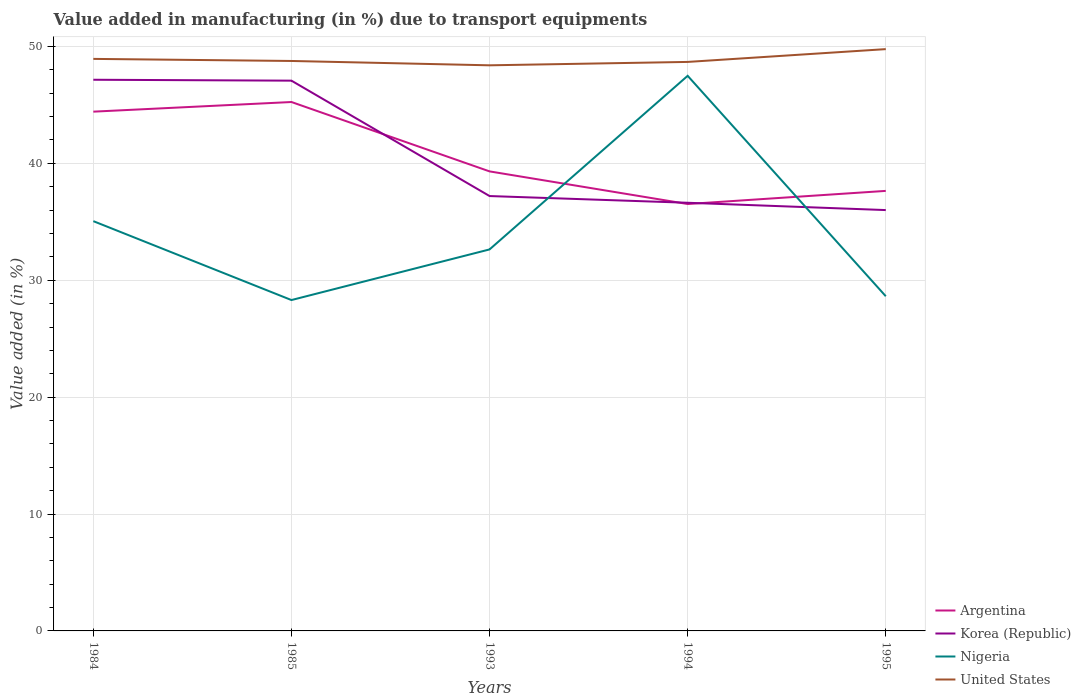How many different coloured lines are there?
Keep it short and to the point. 4. Does the line corresponding to United States intersect with the line corresponding to Nigeria?
Ensure brevity in your answer.  No. Across all years, what is the maximum percentage of value added in manufacturing due to transport equipments in Nigeria?
Your response must be concise. 28.31. In which year was the percentage of value added in manufacturing due to transport equipments in United States maximum?
Provide a succinct answer. 1993. What is the total percentage of value added in manufacturing due to transport equipments in United States in the graph?
Give a very brief answer. 0.55. What is the difference between the highest and the second highest percentage of value added in manufacturing due to transport equipments in Nigeria?
Offer a very short reply. 19.18. How many years are there in the graph?
Provide a succinct answer. 5. What is the difference between two consecutive major ticks on the Y-axis?
Provide a short and direct response. 10. Are the values on the major ticks of Y-axis written in scientific E-notation?
Your answer should be very brief. No. Does the graph contain grids?
Make the answer very short. Yes. What is the title of the graph?
Give a very brief answer. Value added in manufacturing (in %) due to transport equipments. Does "Namibia" appear as one of the legend labels in the graph?
Offer a terse response. No. What is the label or title of the X-axis?
Provide a succinct answer. Years. What is the label or title of the Y-axis?
Your answer should be very brief. Value added (in %). What is the Value added (in %) in Argentina in 1984?
Provide a short and direct response. 44.42. What is the Value added (in %) of Korea (Republic) in 1984?
Give a very brief answer. 47.15. What is the Value added (in %) of Nigeria in 1984?
Ensure brevity in your answer.  35.06. What is the Value added (in %) of United States in 1984?
Offer a very short reply. 48.94. What is the Value added (in %) in Argentina in 1985?
Your answer should be compact. 45.25. What is the Value added (in %) of Korea (Republic) in 1985?
Provide a short and direct response. 47.08. What is the Value added (in %) of Nigeria in 1985?
Offer a terse response. 28.31. What is the Value added (in %) of United States in 1985?
Offer a terse response. 48.76. What is the Value added (in %) of Argentina in 1993?
Give a very brief answer. 39.31. What is the Value added (in %) in Korea (Republic) in 1993?
Provide a succinct answer. 37.21. What is the Value added (in %) of Nigeria in 1993?
Your response must be concise. 32.64. What is the Value added (in %) in United States in 1993?
Provide a short and direct response. 48.39. What is the Value added (in %) in Argentina in 1994?
Provide a succinct answer. 36.52. What is the Value added (in %) in Korea (Republic) in 1994?
Give a very brief answer. 36.63. What is the Value added (in %) in Nigeria in 1994?
Your response must be concise. 47.49. What is the Value added (in %) of United States in 1994?
Your answer should be very brief. 48.68. What is the Value added (in %) in Argentina in 1995?
Give a very brief answer. 37.65. What is the Value added (in %) of Korea (Republic) in 1995?
Provide a short and direct response. 36. What is the Value added (in %) of Nigeria in 1995?
Your answer should be compact. 28.63. What is the Value added (in %) of United States in 1995?
Make the answer very short. 49.77. Across all years, what is the maximum Value added (in %) of Argentina?
Provide a succinct answer. 45.25. Across all years, what is the maximum Value added (in %) of Korea (Republic)?
Give a very brief answer. 47.15. Across all years, what is the maximum Value added (in %) in Nigeria?
Offer a very short reply. 47.49. Across all years, what is the maximum Value added (in %) of United States?
Provide a succinct answer. 49.77. Across all years, what is the minimum Value added (in %) in Argentina?
Offer a terse response. 36.52. Across all years, what is the minimum Value added (in %) of Korea (Republic)?
Your answer should be very brief. 36. Across all years, what is the minimum Value added (in %) of Nigeria?
Your response must be concise. 28.31. Across all years, what is the minimum Value added (in %) in United States?
Offer a terse response. 48.39. What is the total Value added (in %) in Argentina in the graph?
Your answer should be compact. 203.16. What is the total Value added (in %) of Korea (Republic) in the graph?
Your response must be concise. 204.07. What is the total Value added (in %) in Nigeria in the graph?
Ensure brevity in your answer.  172.13. What is the total Value added (in %) of United States in the graph?
Give a very brief answer. 244.54. What is the difference between the Value added (in %) of Argentina in 1984 and that in 1985?
Provide a short and direct response. -0.83. What is the difference between the Value added (in %) of Korea (Republic) in 1984 and that in 1985?
Offer a very short reply. 0.08. What is the difference between the Value added (in %) in Nigeria in 1984 and that in 1985?
Offer a very short reply. 6.75. What is the difference between the Value added (in %) in United States in 1984 and that in 1985?
Offer a very short reply. 0.18. What is the difference between the Value added (in %) of Argentina in 1984 and that in 1993?
Your answer should be compact. 5.11. What is the difference between the Value added (in %) of Korea (Republic) in 1984 and that in 1993?
Provide a succinct answer. 9.95. What is the difference between the Value added (in %) of Nigeria in 1984 and that in 1993?
Give a very brief answer. 2.42. What is the difference between the Value added (in %) of United States in 1984 and that in 1993?
Give a very brief answer. 0.55. What is the difference between the Value added (in %) in Argentina in 1984 and that in 1994?
Offer a very short reply. 7.9. What is the difference between the Value added (in %) of Korea (Republic) in 1984 and that in 1994?
Ensure brevity in your answer.  10.52. What is the difference between the Value added (in %) in Nigeria in 1984 and that in 1994?
Make the answer very short. -12.43. What is the difference between the Value added (in %) of United States in 1984 and that in 1994?
Provide a succinct answer. 0.26. What is the difference between the Value added (in %) in Argentina in 1984 and that in 1995?
Your response must be concise. 6.78. What is the difference between the Value added (in %) in Korea (Republic) in 1984 and that in 1995?
Offer a very short reply. 11.15. What is the difference between the Value added (in %) in Nigeria in 1984 and that in 1995?
Offer a terse response. 6.42. What is the difference between the Value added (in %) in United States in 1984 and that in 1995?
Ensure brevity in your answer.  -0.84. What is the difference between the Value added (in %) of Argentina in 1985 and that in 1993?
Make the answer very short. 5.94. What is the difference between the Value added (in %) of Korea (Republic) in 1985 and that in 1993?
Offer a terse response. 9.87. What is the difference between the Value added (in %) in Nigeria in 1985 and that in 1993?
Make the answer very short. -4.33. What is the difference between the Value added (in %) in United States in 1985 and that in 1993?
Your answer should be compact. 0.37. What is the difference between the Value added (in %) of Argentina in 1985 and that in 1994?
Offer a very short reply. 8.73. What is the difference between the Value added (in %) in Korea (Republic) in 1985 and that in 1994?
Keep it short and to the point. 10.45. What is the difference between the Value added (in %) of Nigeria in 1985 and that in 1994?
Make the answer very short. -19.18. What is the difference between the Value added (in %) of United States in 1985 and that in 1994?
Offer a very short reply. 0.08. What is the difference between the Value added (in %) in Argentina in 1985 and that in 1995?
Your response must be concise. 7.6. What is the difference between the Value added (in %) of Korea (Republic) in 1985 and that in 1995?
Your answer should be compact. 11.07. What is the difference between the Value added (in %) of Nigeria in 1985 and that in 1995?
Your answer should be compact. -0.33. What is the difference between the Value added (in %) in United States in 1985 and that in 1995?
Make the answer very short. -1.01. What is the difference between the Value added (in %) of Argentina in 1993 and that in 1994?
Your response must be concise. 2.79. What is the difference between the Value added (in %) in Korea (Republic) in 1993 and that in 1994?
Your answer should be very brief. 0.57. What is the difference between the Value added (in %) of Nigeria in 1993 and that in 1994?
Provide a short and direct response. -14.85. What is the difference between the Value added (in %) of United States in 1993 and that in 1994?
Make the answer very short. -0.29. What is the difference between the Value added (in %) of Argentina in 1993 and that in 1995?
Your answer should be very brief. 1.67. What is the difference between the Value added (in %) of Korea (Republic) in 1993 and that in 1995?
Ensure brevity in your answer.  1.2. What is the difference between the Value added (in %) in Nigeria in 1993 and that in 1995?
Keep it short and to the point. 4.01. What is the difference between the Value added (in %) in United States in 1993 and that in 1995?
Your answer should be very brief. -1.39. What is the difference between the Value added (in %) in Argentina in 1994 and that in 1995?
Your response must be concise. -1.12. What is the difference between the Value added (in %) of Korea (Republic) in 1994 and that in 1995?
Offer a terse response. 0.63. What is the difference between the Value added (in %) in Nigeria in 1994 and that in 1995?
Give a very brief answer. 18.86. What is the difference between the Value added (in %) of United States in 1994 and that in 1995?
Your answer should be very brief. -1.1. What is the difference between the Value added (in %) of Argentina in 1984 and the Value added (in %) of Korea (Republic) in 1985?
Your answer should be very brief. -2.65. What is the difference between the Value added (in %) in Argentina in 1984 and the Value added (in %) in Nigeria in 1985?
Make the answer very short. 16.12. What is the difference between the Value added (in %) in Argentina in 1984 and the Value added (in %) in United States in 1985?
Your answer should be very brief. -4.34. What is the difference between the Value added (in %) of Korea (Republic) in 1984 and the Value added (in %) of Nigeria in 1985?
Provide a short and direct response. 18.85. What is the difference between the Value added (in %) in Korea (Republic) in 1984 and the Value added (in %) in United States in 1985?
Make the answer very short. -1.61. What is the difference between the Value added (in %) of Nigeria in 1984 and the Value added (in %) of United States in 1985?
Ensure brevity in your answer.  -13.7. What is the difference between the Value added (in %) of Argentina in 1984 and the Value added (in %) of Korea (Republic) in 1993?
Give a very brief answer. 7.22. What is the difference between the Value added (in %) in Argentina in 1984 and the Value added (in %) in Nigeria in 1993?
Provide a succinct answer. 11.79. What is the difference between the Value added (in %) of Argentina in 1984 and the Value added (in %) of United States in 1993?
Your answer should be very brief. -3.97. What is the difference between the Value added (in %) in Korea (Republic) in 1984 and the Value added (in %) in Nigeria in 1993?
Offer a terse response. 14.52. What is the difference between the Value added (in %) of Korea (Republic) in 1984 and the Value added (in %) of United States in 1993?
Provide a succinct answer. -1.24. What is the difference between the Value added (in %) in Nigeria in 1984 and the Value added (in %) in United States in 1993?
Your answer should be compact. -13.33. What is the difference between the Value added (in %) in Argentina in 1984 and the Value added (in %) in Korea (Republic) in 1994?
Offer a very short reply. 7.79. What is the difference between the Value added (in %) in Argentina in 1984 and the Value added (in %) in Nigeria in 1994?
Your response must be concise. -3.07. What is the difference between the Value added (in %) in Argentina in 1984 and the Value added (in %) in United States in 1994?
Keep it short and to the point. -4.25. What is the difference between the Value added (in %) of Korea (Republic) in 1984 and the Value added (in %) of Nigeria in 1994?
Provide a short and direct response. -0.34. What is the difference between the Value added (in %) of Korea (Republic) in 1984 and the Value added (in %) of United States in 1994?
Provide a short and direct response. -1.53. What is the difference between the Value added (in %) of Nigeria in 1984 and the Value added (in %) of United States in 1994?
Give a very brief answer. -13.62. What is the difference between the Value added (in %) of Argentina in 1984 and the Value added (in %) of Korea (Republic) in 1995?
Provide a short and direct response. 8.42. What is the difference between the Value added (in %) of Argentina in 1984 and the Value added (in %) of Nigeria in 1995?
Offer a terse response. 15.79. What is the difference between the Value added (in %) in Argentina in 1984 and the Value added (in %) in United States in 1995?
Offer a terse response. -5.35. What is the difference between the Value added (in %) in Korea (Republic) in 1984 and the Value added (in %) in Nigeria in 1995?
Provide a short and direct response. 18.52. What is the difference between the Value added (in %) of Korea (Republic) in 1984 and the Value added (in %) of United States in 1995?
Offer a very short reply. -2.62. What is the difference between the Value added (in %) in Nigeria in 1984 and the Value added (in %) in United States in 1995?
Your response must be concise. -14.72. What is the difference between the Value added (in %) in Argentina in 1985 and the Value added (in %) in Korea (Republic) in 1993?
Ensure brevity in your answer.  8.04. What is the difference between the Value added (in %) of Argentina in 1985 and the Value added (in %) of Nigeria in 1993?
Your response must be concise. 12.61. What is the difference between the Value added (in %) in Argentina in 1985 and the Value added (in %) in United States in 1993?
Your answer should be very brief. -3.14. What is the difference between the Value added (in %) in Korea (Republic) in 1985 and the Value added (in %) in Nigeria in 1993?
Give a very brief answer. 14.44. What is the difference between the Value added (in %) in Korea (Republic) in 1985 and the Value added (in %) in United States in 1993?
Your answer should be compact. -1.31. What is the difference between the Value added (in %) of Nigeria in 1985 and the Value added (in %) of United States in 1993?
Provide a succinct answer. -20.08. What is the difference between the Value added (in %) in Argentina in 1985 and the Value added (in %) in Korea (Republic) in 1994?
Make the answer very short. 8.62. What is the difference between the Value added (in %) of Argentina in 1985 and the Value added (in %) of Nigeria in 1994?
Your answer should be very brief. -2.24. What is the difference between the Value added (in %) in Argentina in 1985 and the Value added (in %) in United States in 1994?
Offer a terse response. -3.43. What is the difference between the Value added (in %) in Korea (Republic) in 1985 and the Value added (in %) in Nigeria in 1994?
Offer a very short reply. -0.41. What is the difference between the Value added (in %) in Korea (Republic) in 1985 and the Value added (in %) in United States in 1994?
Make the answer very short. -1.6. What is the difference between the Value added (in %) of Nigeria in 1985 and the Value added (in %) of United States in 1994?
Offer a very short reply. -20.37. What is the difference between the Value added (in %) of Argentina in 1985 and the Value added (in %) of Korea (Republic) in 1995?
Offer a very short reply. 9.25. What is the difference between the Value added (in %) in Argentina in 1985 and the Value added (in %) in Nigeria in 1995?
Provide a short and direct response. 16.62. What is the difference between the Value added (in %) in Argentina in 1985 and the Value added (in %) in United States in 1995?
Give a very brief answer. -4.52. What is the difference between the Value added (in %) in Korea (Republic) in 1985 and the Value added (in %) in Nigeria in 1995?
Provide a succinct answer. 18.44. What is the difference between the Value added (in %) in Korea (Republic) in 1985 and the Value added (in %) in United States in 1995?
Give a very brief answer. -2.7. What is the difference between the Value added (in %) of Nigeria in 1985 and the Value added (in %) of United States in 1995?
Offer a terse response. -21.47. What is the difference between the Value added (in %) of Argentina in 1993 and the Value added (in %) of Korea (Republic) in 1994?
Your response must be concise. 2.68. What is the difference between the Value added (in %) in Argentina in 1993 and the Value added (in %) in Nigeria in 1994?
Give a very brief answer. -8.18. What is the difference between the Value added (in %) of Argentina in 1993 and the Value added (in %) of United States in 1994?
Your answer should be compact. -9.37. What is the difference between the Value added (in %) of Korea (Republic) in 1993 and the Value added (in %) of Nigeria in 1994?
Give a very brief answer. -10.29. What is the difference between the Value added (in %) of Korea (Republic) in 1993 and the Value added (in %) of United States in 1994?
Your response must be concise. -11.47. What is the difference between the Value added (in %) in Nigeria in 1993 and the Value added (in %) in United States in 1994?
Make the answer very short. -16.04. What is the difference between the Value added (in %) in Argentina in 1993 and the Value added (in %) in Korea (Republic) in 1995?
Offer a very short reply. 3.31. What is the difference between the Value added (in %) in Argentina in 1993 and the Value added (in %) in Nigeria in 1995?
Offer a terse response. 10.68. What is the difference between the Value added (in %) of Argentina in 1993 and the Value added (in %) of United States in 1995?
Your answer should be compact. -10.46. What is the difference between the Value added (in %) of Korea (Republic) in 1993 and the Value added (in %) of Nigeria in 1995?
Make the answer very short. 8.57. What is the difference between the Value added (in %) in Korea (Republic) in 1993 and the Value added (in %) in United States in 1995?
Your response must be concise. -12.57. What is the difference between the Value added (in %) of Nigeria in 1993 and the Value added (in %) of United States in 1995?
Keep it short and to the point. -17.14. What is the difference between the Value added (in %) of Argentina in 1994 and the Value added (in %) of Korea (Republic) in 1995?
Your response must be concise. 0.52. What is the difference between the Value added (in %) in Argentina in 1994 and the Value added (in %) in Nigeria in 1995?
Your answer should be very brief. 7.89. What is the difference between the Value added (in %) of Argentina in 1994 and the Value added (in %) of United States in 1995?
Give a very brief answer. -13.25. What is the difference between the Value added (in %) of Korea (Republic) in 1994 and the Value added (in %) of Nigeria in 1995?
Give a very brief answer. 8. What is the difference between the Value added (in %) in Korea (Republic) in 1994 and the Value added (in %) in United States in 1995?
Offer a very short reply. -13.14. What is the difference between the Value added (in %) in Nigeria in 1994 and the Value added (in %) in United States in 1995?
Your answer should be compact. -2.28. What is the average Value added (in %) in Argentina per year?
Your response must be concise. 40.63. What is the average Value added (in %) of Korea (Republic) per year?
Offer a very short reply. 40.81. What is the average Value added (in %) of Nigeria per year?
Your answer should be compact. 34.43. What is the average Value added (in %) in United States per year?
Your answer should be very brief. 48.91. In the year 1984, what is the difference between the Value added (in %) in Argentina and Value added (in %) in Korea (Republic)?
Ensure brevity in your answer.  -2.73. In the year 1984, what is the difference between the Value added (in %) in Argentina and Value added (in %) in Nigeria?
Your answer should be very brief. 9.37. In the year 1984, what is the difference between the Value added (in %) in Argentina and Value added (in %) in United States?
Provide a succinct answer. -4.51. In the year 1984, what is the difference between the Value added (in %) in Korea (Republic) and Value added (in %) in Nigeria?
Provide a succinct answer. 12.1. In the year 1984, what is the difference between the Value added (in %) of Korea (Republic) and Value added (in %) of United States?
Offer a terse response. -1.78. In the year 1984, what is the difference between the Value added (in %) in Nigeria and Value added (in %) in United States?
Your answer should be compact. -13.88. In the year 1985, what is the difference between the Value added (in %) in Argentina and Value added (in %) in Korea (Republic)?
Provide a succinct answer. -1.83. In the year 1985, what is the difference between the Value added (in %) of Argentina and Value added (in %) of Nigeria?
Your answer should be very brief. 16.94. In the year 1985, what is the difference between the Value added (in %) in Argentina and Value added (in %) in United States?
Provide a short and direct response. -3.51. In the year 1985, what is the difference between the Value added (in %) of Korea (Republic) and Value added (in %) of Nigeria?
Your response must be concise. 18.77. In the year 1985, what is the difference between the Value added (in %) of Korea (Republic) and Value added (in %) of United States?
Offer a very short reply. -1.68. In the year 1985, what is the difference between the Value added (in %) in Nigeria and Value added (in %) in United States?
Offer a terse response. -20.45. In the year 1993, what is the difference between the Value added (in %) of Argentina and Value added (in %) of Korea (Republic)?
Give a very brief answer. 2.11. In the year 1993, what is the difference between the Value added (in %) in Argentina and Value added (in %) in Nigeria?
Your response must be concise. 6.68. In the year 1993, what is the difference between the Value added (in %) of Argentina and Value added (in %) of United States?
Your answer should be very brief. -9.08. In the year 1993, what is the difference between the Value added (in %) of Korea (Republic) and Value added (in %) of Nigeria?
Offer a very short reply. 4.57. In the year 1993, what is the difference between the Value added (in %) of Korea (Republic) and Value added (in %) of United States?
Ensure brevity in your answer.  -11.18. In the year 1993, what is the difference between the Value added (in %) of Nigeria and Value added (in %) of United States?
Offer a terse response. -15.75. In the year 1994, what is the difference between the Value added (in %) in Argentina and Value added (in %) in Korea (Republic)?
Ensure brevity in your answer.  -0.11. In the year 1994, what is the difference between the Value added (in %) in Argentina and Value added (in %) in Nigeria?
Offer a very short reply. -10.97. In the year 1994, what is the difference between the Value added (in %) of Argentina and Value added (in %) of United States?
Provide a short and direct response. -12.16. In the year 1994, what is the difference between the Value added (in %) of Korea (Republic) and Value added (in %) of Nigeria?
Make the answer very short. -10.86. In the year 1994, what is the difference between the Value added (in %) in Korea (Republic) and Value added (in %) in United States?
Ensure brevity in your answer.  -12.05. In the year 1994, what is the difference between the Value added (in %) in Nigeria and Value added (in %) in United States?
Your response must be concise. -1.19. In the year 1995, what is the difference between the Value added (in %) of Argentina and Value added (in %) of Korea (Republic)?
Keep it short and to the point. 1.64. In the year 1995, what is the difference between the Value added (in %) of Argentina and Value added (in %) of Nigeria?
Make the answer very short. 9.01. In the year 1995, what is the difference between the Value added (in %) of Argentina and Value added (in %) of United States?
Your answer should be compact. -12.13. In the year 1995, what is the difference between the Value added (in %) in Korea (Republic) and Value added (in %) in Nigeria?
Keep it short and to the point. 7.37. In the year 1995, what is the difference between the Value added (in %) of Korea (Republic) and Value added (in %) of United States?
Keep it short and to the point. -13.77. In the year 1995, what is the difference between the Value added (in %) of Nigeria and Value added (in %) of United States?
Your answer should be very brief. -21.14. What is the ratio of the Value added (in %) in Argentina in 1984 to that in 1985?
Provide a succinct answer. 0.98. What is the ratio of the Value added (in %) of Nigeria in 1984 to that in 1985?
Give a very brief answer. 1.24. What is the ratio of the Value added (in %) of Argentina in 1984 to that in 1993?
Provide a succinct answer. 1.13. What is the ratio of the Value added (in %) of Korea (Republic) in 1984 to that in 1993?
Give a very brief answer. 1.27. What is the ratio of the Value added (in %) in Nigeria in 1984 to that in 1993?
Provide a short and direct response. 1.07. What is the ratio of the Value added (in %) in United States in 1984 to that in 1993?
Provide a short and direct response. 1.01. What is the ratio of the Value added (in %) in Argentina in 1984 to that in 1994?
Keep it short and to the point. 1.22. What is the ratio of the Value added (in %) of Korea (Republic) in 1984 to that in 1994?
Make the answer very short. 1.29. What is the ratio of the Value added (in %) of Nigeria in 1984 to that in 1994?
Keep it short and to the point. 0.74. What is the ratio of the Value added (in %) in Argentina in 1984 to that in 1995?
Make the answer very short. 1.18. What is the ratio of the Value added (in %) in Korea (Republic) in 1984 to that in 1995?
Provide a short and direct response. 1.31. What is the ratio of the Value added (in %) in Nigeria in 1984 to that in 1995?
Provide a short and direct response. 1.22. What is the ratio of the Value added (in %) in United States in 1984 to that in 1995?
Your answer should be compact. 0.98. What is the ratio of the Value added (in %) of Argentina in 1985 to that in 1993?
Provide a short and direct response. 1.15. What is the ratio of the Value added (in %) in Korea (Republic) in 1985 to that in 1993?
Give a very brief answer. 1.27. What is the ratio of the Value added (in %) of Nigeria in 1985 to that in 1993?
Provide a short and direct response. 0.87. What is the ratio of the Value added (in %) in United States in 1985 to that in 1993?
Provide a succinct answer. 1.01. What is the ratio of the Value added (in %) of Argentina in 1985 to that in 1994?
Provide a succinct answer. 1.24. What is the ratio of the Value added (in %) in Korea (Republic) in 1985 to that in 1994?
Your answer should be very brief. 1.29. What is the ratio of the Value added (in %) in Nigeria in 1985 to that in 1994?
Your answer should be compact. 0.6. What is the ratio of the Value added (in %) in United States in 1985 to that in 1994?
Give a very brief answer. 1. What is the ratio of the Value added (in %) of Argentina in 1985 to that in 1995?
Give a very brief answer. 1.2. What is the ratio of the Value added (in %) of Korea (Republic) in 1985 to that in 1995?
Give a very brief answer. 1.31. What is the ratio of the Value added (in %) in Nigeria in 1985 to that in 1995?
Ensure brevity in your answer.  0.99. What is the ratio of the Value added (in %) in United States in 1985 to that in 1995?
Your response must be concise. 0.98. What is the ratio of the Value added (in %) of Argentina in 1993 to that in 1994?
Your answer should be compact. 1.08. What is the ratio of the Value added (in %) in Korea (Republic) in 1993 to that in 1994?
Provide a short and direct response. 1.02. What is the ratio of the Value added (in %) in Nigeria in 1993 to that in 1994?
Offer a very short reply. 0.69. What is the ratio of the Value added (in %) of Argentina in 1993 to that in 1995?
Ensure brevity in your answer.  1.04. What is the ratio of the Value added (in %) in Nigeria in 1993 to that in 1995?
Offer a very short reply. 1.14. What is the ratio of the Value added (in %) in United States in 1993 to that in 1995?
Offer a very short reply. 0.97. What is the ratio of the Value added (in %) in Argentina in 1994 to that in 1995?
Offer a very short reply. 0.97. What is the ratio of the Value added (in %) in Korea (Republic) in 1994 to that in 1995?
Your answer should be compact. 1.02. What is the ratio of the Value added (in %) of Nigeria in 1994 to that in 1995?
Make the answer very short. 1.66. What is the difference between the highest and the second highest Value added (in %) of Argentina?
Offer a very short reply. 0.83. What is the difference between the highest and the second highest Value added (in %) of Korea (Republic)?
Offer a terse response. 0.08. What is the difference between the highest and the second highest Value added (in %) in Nigeria?
Make the answer very short. 12.43. What is the difference between the highest and the second highest Value added (in %) of United States?
Give a very brief answer. 0.84. What is the difference between the highest and the lowest Value added (in %) of Argentina?
Offer a very short reply. 8.73. What is the difference between the highest and the lowest Value added (in %) of Korea (Republic)?
Your answer should be compact. 11.15. What is the difference between the highest and the lowest Value added (in %) of Nigeria?
Give a very brief answer. 19.18. What is the difference between the highest and the lowest Value added (in %) of United States?
Keep it short and to the point. 1.39. 